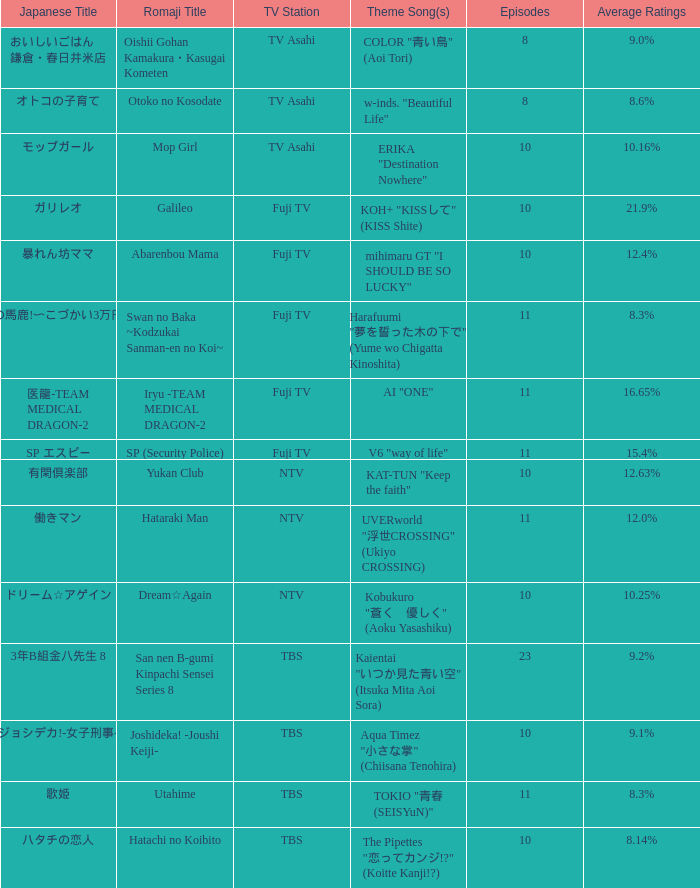What Episode has a Theme Song of koh+ "kissして" (kiss shite)? 10.0. Could you parse the entire table? {'header': ['Japanese Title', 'Romaji Title', 'TV Station', 'Theme Song(s)', 'Episodes', 'Average Ratings'], 'rows': [['おいしいごはん 鎌倉・春日井米店', 'Oishii Gohan Kamakura・Kasugai Kometen', 'TV Asahi', 'COLOR "青い鳥" (Aoi Tori)', '8', '9.0%'], ['オトコの子育て', 'Otoko no Kosodate', 'TV Asahi', 'w-inds. "Beautiful Life"', '8', '8.6%'], ['モップガール', 'Mop Girl', 'TV Asahi', 'ERIKA "Destination Nowhere"', '10', '10.16%'], ['ガリレオ', 'Galileo', 'Fuji TV', 'KOH+ "KISSして" (KISS Shite)', '10', '21.9%'], ['暴れん坊ママ', 'Abarenbou Mama', 'Fuji TV', 'mihimaru GT "I SHOULD BE SO LUCKY"', '10', '12.4%'], ['スワンの馬鹿!〜こづかい3万円の恋〜', 'Swan no Baka ~Kodzukai Sanman-en no Koi~', 'Fuji TV', 'Harafuumi "夢を誓った木の下で" (Yume wo Chigatta Kinoshita)', '11', '8.3%'], ['医龍-TEAM MEDICAL DRAGON-2', 'Iryu -TEAM MEDICAL DRAGON-2', 'Fuji TV', 'AI "ONE"', '11', '16.65%'], ['SP エスピー', 'SP (Security Police)', 'Fuji TV', 'V6 "way of life"', '11', '15.4%'], ['有閑倶楽部', 'Yukan Club', 'NTV', 'KAT-TUN "Keep the faith"', '10', '12.63%'], ['働きマン', 'Hataraki Man', 'NTV', 'UVERworld "浮世CROSSING" (Ukiyo CROSSING)', '11', '12.0%'], ['ドリーム☆アゲイン', 'Dream☆Again', 'NTV', 'Kobukuro "蒼く\u3000優しく" (Aoku Yasashiku)', '10', '10.25%'], ['3年B組金八先生 8', 'San nen B-gumi Kinpachi Sensei Series 8', 'TBS', 'Kaientai "いつか見た青い空" (Itsuka Mita Aoi Sora)', '23', '9.2%'], ['ジョシデカ!-女子刑事-', 'Joshideka! -Joushi Keiji-', 'TBS', 'Aqua Timez "小さな掌" (Chiisana Tenohira)', '10', '9.1%'], ['歌姫', 'Utahime', 'TBS', 'TOKIO "青春 (SEISYuN)"', '11', '8.3%'], ['ハタチの恋人', 'Hatachi no Koibito', 'TBS', 'The Pipettes "恋ってカンジ!?" (Koitte Kanji!?)', '10', '8.14%']]} 